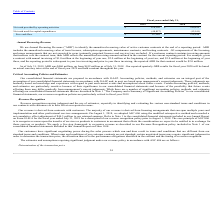According to Guidewire Software's financial document, What does free cash flow take into account? Based on the financial document, the answer is the impact of changes in deferred revenue, which reflects the receipt of cash payment for products before they are recognized as revenue, and unbilled accounts receivable, which reflects revenue that has been recognized that has yet to be invoiced to our customers.. Also, What impacted the net cash provided by (used in) operating activities? Based on the financial document, the answer is the timing of invoicing and collections of accounts receivable, the timing and amount of annual bonus payments, as well as payroll and tax payments.. Also, What was the Net cash provided by operating activities in 2019 and 2018 respectively? The document shows two values: $116,126 and $140,459. From the document: "cash provided by operating activities $ 116,126 $ 140,459 Net cash provided by operating activities $ 116,126 $ 140,459..." Additionally, In which year was Free cash flow less than 100,000 thousands? According to the financial document, 2019. The relevant text states: "2019 2018..." Also, can you calculate: What was the average Net cash used for capital expenditures for 2018 and 2019? To answer this question, I need to perform calculations using the financial data. The calculation is: -(48,857 + 12,011) / 2, which equals -30434 (in thousands). This is based on the information: "Net cash used for capital expenditures (48,857) (12,011) Net cash used for capital expenditures (48,857) (12,011)..." The key data points involved are: 12,011, 48,857. Also, can you calculate: What was the change in the Net cash provided by operating activities from 2018 to 2019? Based on the calculation: 116,126 - 140,459, the result is -24333 (in thousands). This is based on the information: "Net cash provided by operating activities $ 116,126 $ 140,459 cash provided by operating activities $ 116,126 $ 140,459..." The key data points involved are: 116,126, 140,459. 